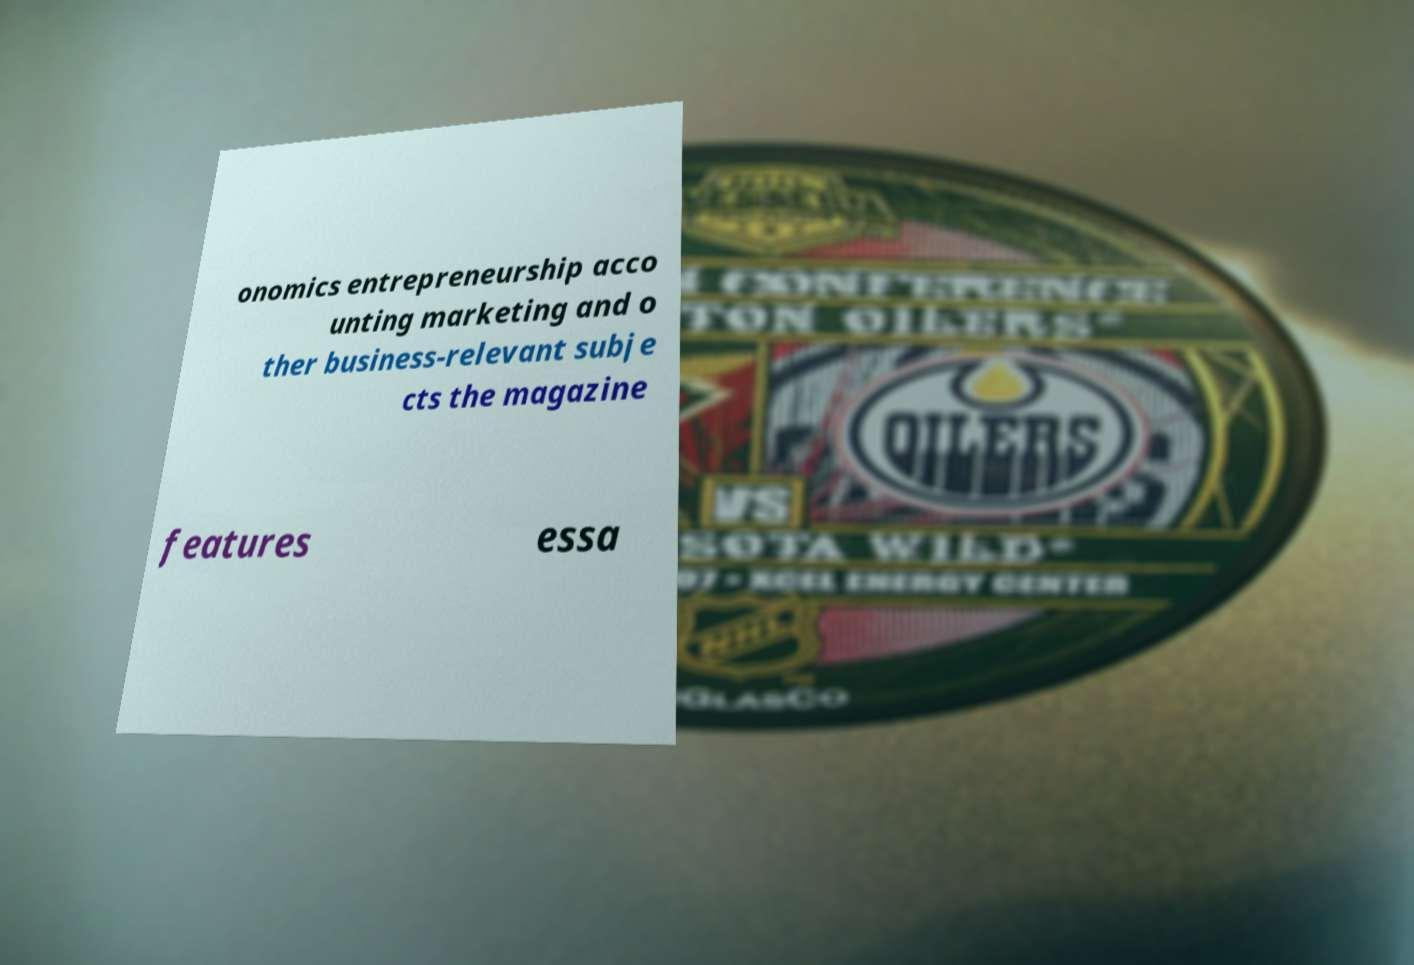Can you accurately transcribe the text from the provided image for me? onomics entrepreneurship acco unting marketing and o ther business-relevant subje cts the magazine features essa 